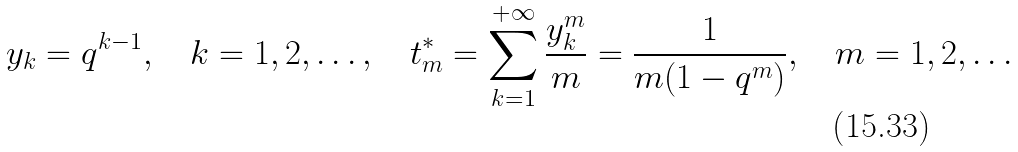<formula> <loc_0><loc_0><loc_500><loc_500>y _ { k } = q ^ { k - 1 } , \quad k = 1 , 2 , \dots , \quad t ^ { * } _ { m } = \sum _ { k = 1 } ^ { + \infty } \frac { y _ { k } ^ { m } } { m } = \frac { 1 } { m ( 1 - q ^ { m } ) } , \quad m = 1 , 2 , \dots</formula> 